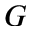<formula> <loc_0><loc_0><loc_500><loc_500>G</formula> 